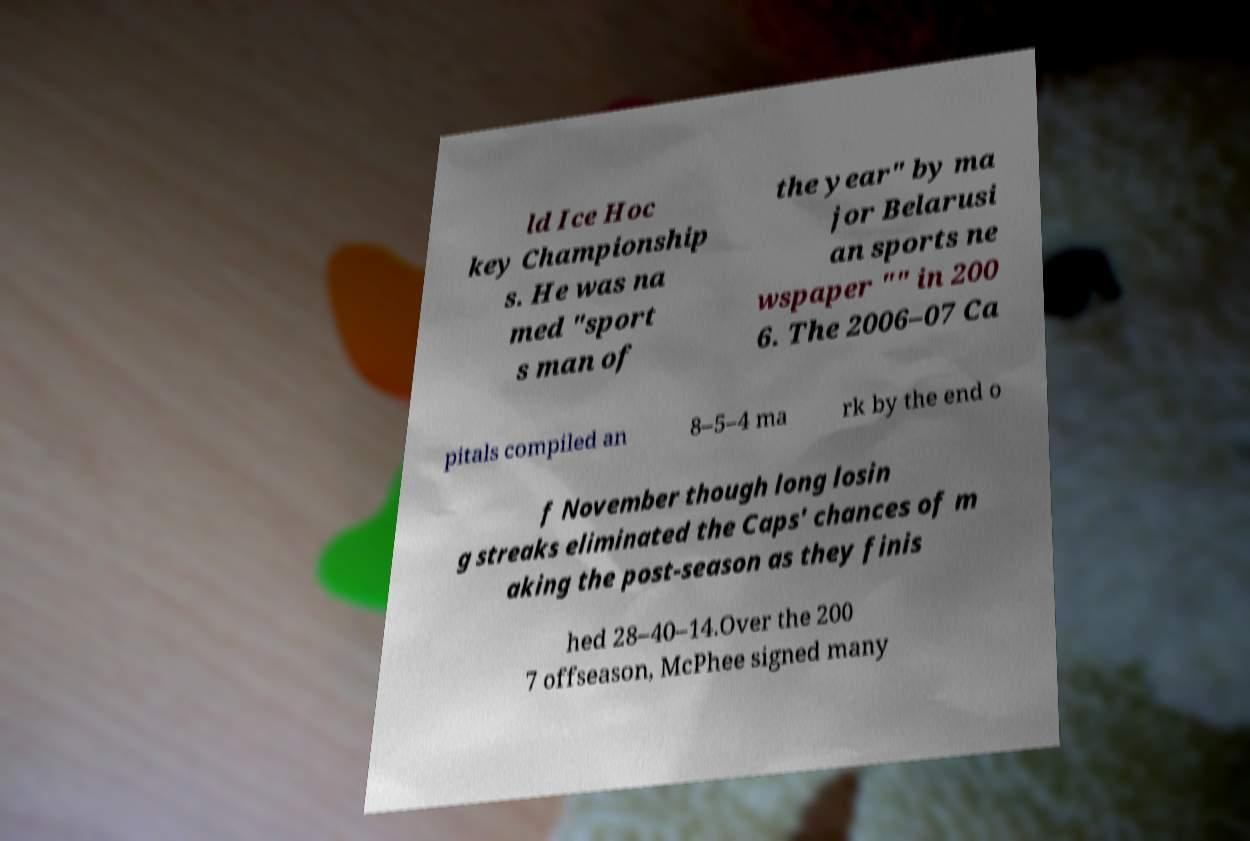I need the written content from this picture converted into text. Can you do that? ld Ice Hoc key Championship s. He was na med "sport s man of the year" by ma jor Belarusi an sports ne wspaper "" in 200 6. The 2006–07 Ca pitals compiled an 8–5–4 ma rk by the end o f November though long losin g streaks eliminated the Caps' chances of m aking the post-season as they finis hed 28–40–14.Over the 200 7 offseason, McPhee signed many 